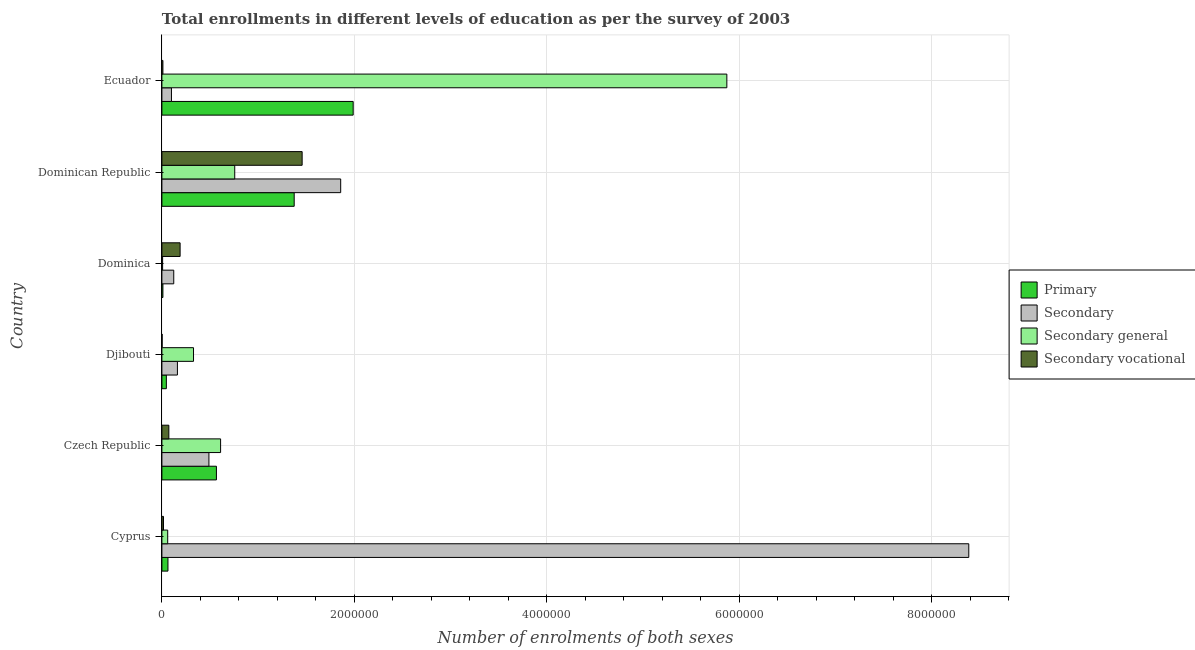How many different coloured bars are there?
Provide a short and direct response. 4. How many bars are there on the 3rd tick from the top?
Provide a short and direct response. 4. What is the label of the 3rd group of bars from the top?
Ensure brevity in your answer.  Dominica. In how many cases, is the number of bars for a given country not equal to the number of legend labels?
Your response must be concise. 0. What is the number of enrolments in primary education in Ecuador?
Ensure brevity in your answer.  1.99e+06. Across all countries, what is the maximum number of enrolments in secondary vocational education?
Give a very brief answer. 1.46e+06. Across all countries, what is the minimum number of enrolments in primary education?
Offer a very short reply. 1.05e+04. In which country was the number of enrolments in primary education maximum?
Your answer should be compact. Ecuador. In which country was the number of enrolments in secondary vocational education minimum?
Offer a very short reply. Djibouti. What is the total number of enrolments in secondary general education in the graph?
Your answer should be very brief. 7.63e+06. What is the difference between the number of enrolments in primary education in Dominica and that in Ecuador?
Keep it short and to the point. -1.98e+06. What is the difference between the number of enrolments in secondary vocational education in Czech Republic and the number of enrolments in secondary education in Djibouti?
Provide a short and direct response. -8.91e+04. What is the average number of enrolments in secondary general education per country?
Give a very brief answer. 1.27e+06. What is the difference between the number of enrolments in secondary education and number of enrolments in secondary vocational education in Dominica?
Give a very brief answer. -6.62e+04. In how many countries, is the number of enrolments in secondary general education greater than 800000 ?
Make the answer very short. 1. What is the ratio of the number of enrolments in secondary general education in Czech Republic to that in Djibouti?
Your answer should be very brief. 1.86. Is the difference between the number of enrolments in secondary education in Dominican Republic and Ecuador greater than the difference between the number of enrolments in primary education in Dominican Republic and Ecuador?
Ensure brevity in your answer.  Yes. What is the difference between the highest and the second highest number of enrolments in secondary vocational education?
Your answer should be very brief. 1.27e+06. What is the difference between the highest and the lowest number of enrolments in primary education?
Make the answer very short. 1.98e+06. Is the sum of the number of enrolments in primary education in Czech Republic and Dominica greater than the maximum number of enrolments in secondary vocational education across all countries?
Make the answer very short. No. What does the 4th bar from the top in Dominica represents?
Your response must be concise. Primary. What does the 1st bar from the bottom in Dominican Republic represents?
Your response must be concise. Primary. How many bars are there?
Make the answer very short. 24. Are all the bars in the graph horizontal?
Provide a short and direct response. Yes. Are the values on the major ticks of X-axis written in scientific E-notation?
Offer a very short reply. No. Does the graph contain any zero values?
Make the answer very short. No. How are the legend labels stacked?
Give a very brief answer. Vertical. What is the title of the graph?
Ensure brevity in your answer.  Total enrollments in different levels of education as per the survey of 2003. Does "Secondary vocational" appear as one of the legend labels in the graph?
Make the answer very short. Yes. What is the label or title of the X-axis?
Offer a terse response. Number of enrolments of both sexes. What is the label or title of the Y-axis?
Offer a very short reply. Country. What is the Number of enrolments of both sexes in Primary in Cyprus?
Your answer should be compact. 6.29e+04. What is the Number of enrolments of both sexes in Secondary in Cyprus?
Your answer should be compact. 8.38e+06. What is the Number of enrolments of both sexes of Secondary general in Cyprus?
Give a very brief answer. 6.03e+04. What is the Number of enrolments of both sexes of Secondary vocational in Cyprus?
Your response must be concise. 1.65e+04. What is the Number of enrolments of both sexes of Primary in Czech Republic?
Your response must be concise. 5.67e+05. What is the Number of enrolments of both sexes of Secondary in Czech Republic?
Offer a very short reply. 4.89e+05. What is the Number of enrolments of both sexes in Secondary general in Czech Republic?
Provide a succinct answer. 6.10e+05. What is the Number of enrolments of both sexes in Secondary vocational in Czech Republic?
Keep it short and to the point. 7.22e+04. What is the Number of enrolments of both sexes in Primary in Djibouti?
Offer a terse response. 4.64e+04. What is the Number of enrolments of both sexes in Secondary in Djibouti?
Your answer should be compact. 1.61e+05. What is the Number of enrolments of both sexes in Secondary general in Djibouti?
Give a very brief answer. 3.29e+05. What is the Number of enrolments of both sexes in Secondary vocational in Djibouti?
Your response must be concise. 2319. What is the Number of enrolments of both sexes of Primary in Dominica?
Your answer should be very brief. 1.05e+04. What is the Number of enrolments of both sexes of Secondary in Dominica?
Your answer should be very brief. 1.23e+05. What is the Number of enrolments of both sexes of Secondary general in Dominica?
Provide a succinct answer. 7318. What is the Number of enrolments of both sexes of Secondary vocational in Dominica?
Offer a terse response. 1.89e+05. What is the Number of enrolments of both sexes of Primary in Dominican Republic?
Give a very brief answer. 1.37e+06. What is the Number of enrolments of both sexes of Secondary in Dominican Republic?
Your answer should be very brief. 1.86e+06. What is the Number of enrolments of both sexes of Secondary general in Dominican Republic?
Your response must be concise. 7.57e+05. What is the Number of enrolments of both sexes of Secondary vocational in Dominican Republic?
Your answer should be very brief. 1.46e+06. What is the Number of enrolments of both sexes of Primary in Ecuador?
Your response must be concise. 1.99e+06. What is the Number of enrolments of both sexes of Secondary in Ecuador?
Keep it short and to the point. 9.92e+04. What is the Number of enrolments of both sexes of Secondary general in Ecuador?
Give a very brief answer. 5.87e+06. What is the Number of enrolments of both sexes in Secondary vocational in Ecuador?
Keep it short and to the point. 1.04e+04. Across all countries, what is the maximum Number of enrolments of both sexes in Primary?
Your answer should be very brief. 1.99e+06. Across all countries, what is the maximum Number of enrolments of both sexes in Secondary?
Offer a terse response. 8.38e+06. Across all countries, what is the maximum Number of enrolments of both sexes of Secondary general?
Your answer should be very brief. 5.87e+06. Across all countries, what is the maximum Number of enrolments of both sexes of Secondary vocational?
Ensure brevity in your answer.  1.46e+06. Across all countries, what is the minimum Number of enrolments of both sexes in Primary?
Provide a short and direct response. 1.05e+04. Across all countries, what is the minimum Number of enrolments of both sexes in Secondary?
Ensure brevity in your answer.  9.92e+04. Across all countries, what is the minimum Number of enrolments of both sexes of Secondary general?
Provide a short and direct response. 7318. Across all countries, what is the minimum Number of enrolments of both sexes in Secondary vocational?
Offer a terse response. 2319. What is the total Number of enrolments of both sexes in Primary in the graph?
Make the answer very short. 4.05e+06. What is the total Number of enrolments of both sexes in Secondary in the graph?
Keep it short and to the point. 1.11e+07. What is the total Number of enrolments of both sexes in Secondary general in the graph?
Give a very brief answer. 7.63e+06. What is the total Number of enrolments of both sexes in Secondary vocational in the graph?
Provide a short and direct response. 1.75e+06. What is the difference between the Number of enrolments of both sexes in Primary in Cyprus and that in Czech Republic?
Ensure brevity in your answer.  -5.04e+05. What is the difference between the Number of enrolments of both sexes in Secondary in Cyprus and that in Czech Republic?
Your answer should be compact. 7.90e+06. What is the difference between the Number of enrolments of both sexes of Secondary general in Cyprus and that in Czech Republic?
Offer a very short reply. -5.49e+05. What is the difference between the Number of enrolments of both sexes in Secondary vocational in Cyprus and that in Czech Republic?
Provide a succinct answer. -5.56e+04. What is the difference between the Number of enrolments of both sexes of Primary in Cyprus and that in Djibouti?
Your answer should be compact. 1.65e+04. What is the difference between the Number of enrolments of both sexes of Secondary in Cyprus and that in Djibouti?
Make the answer very short. 8.22e+06. What is the difference between the Number of enrolments of both sexes in Secondary general in Cyprus and that in Djibouti?
Offer a very short reply. -2.68e+05. What is the difference between the Number of enrolments of both sexes of Secondary vocational in Cyprus and that in Djibouti?
Your answer should be very brief. 1.42e+04. What is the difference between the Number of enrolments of both sexes of Primary in Cyprus and that in Dominica?
Ensure brevity in your answer.  5.24e+04. What is the difference between the Number of enrolments of both sexes in Secondary in Cyprus and that in Dominica?
Offer a very short reply. 8.26e+06. What is the difference between the Number of enrolments of both sexes of Secondary general in Cyprus and that in Dominica?
Ensure brevity in your answer.  5.30e+04. What is the difference between the Number of enrolments of both sexes of Secondary vocational in Cyprus and that in Dominica?
Your answer should be very brief. -1.73e+05. What is the difference between the Number of enrolments of both sexes in Primary in Cyprus and that in Dominican Republic?
Ensure brevity in your answer.  -1.31e+06. What is the difference between the Number of enrolments of both sexes of Secondary in Cyprus and that in Dominican Republic?
Offer a terse response. 6.53e+06. What is the difference between the Number of enrolments of both sexes in Secondary general in Cyprus and that in Dominican Republic?
Ensure brevity in your answer.  -6.96e+05. What is the difference between the Number of enrolments of both sexes of Secondary vocational in Cyprus and that in Dominican Republic?
Keep it short and to the point. -1.44e+06. What is the difference between the Number of enrolments of both sexes in Primary in Cyprus and that in Ecuador?
Your answer should be compact. -1.92e+06. What is the difference between the Number of enrolments of both sexes of Secondary in Cyprus and that in Ecuador?
Your response must be concise. 8.28e+06. What is the difference between the Number of enrolments of both sexes of Secondary general in Cyprus and that in Ecuador?
Your answer should be very brief. -5.81e+06. What is the difference between the Number of enrolments of both sexes of Secondary vocational in Cyprus and that in Ecuador?
Your answer should be compact. 6096. What is the difference between the Number of enrolments of both sexes of Primary in Czech Republic and that in Djibouti?
Give a very brief answer. 5.20e+05. What is the difference between the Number of enrolments of both sexes of Secondary in Czech Republic and that in Djibouti?
Ensure brevity in your answer.  3.27e+05. What is the difference between the Number of enrolments of both sexes of Secondary general in Czech Republic and that in Djibouti?
Your response must be concise. 2.81e+05. What is the difference between the Number of enrolments of both sexes of Secondary vocational in Czech Republic and that in Djibouti?
Your answer should be very brief. 6.98e+04. What is the difference between the Number of enrolments of both sexes in Primary in Czech Republic and that in Dominica?
Offer a terse response. 5.56e+05. What is the difference between the Number of enrolments of both sexes in Secondary in Czech Republic and that in Dominica?
Your answer should be compact. 3.65e+05. What is the difference between the Number of enrolments of both sexes in Secondary general in Czech Republic and that in Dominica?
Provide a short and direct response. 6.03e+05. What is the difference between the Number of enrolments of both sexes in Secondary vocational in Czech Republic and that in Dominica?
Offer a terse response. -1.17e+05. What is the difference between the Number of enrolments of both sexes of Primary in Czech Republic and that in Dominican Republic?
Provide a short and direct response. -8.08e+05. What is the difference between the Number of enrolments of both sexes in Secondary in Czech Republic and that in Dominican Republic?
Offer a very short reply. -1.37e+06. What is the difference between the Number of enrolments of both sexes in Secondary general in Czech Republic and that in Dominican Republic?
Ensure brevity in your answer.  -1.47e+05. What is the difference between the Number of enrolments of both sexes in Secondary vocational in Czech Republic and that in Dominican Republic?
Keep it short and to the point. -1.39e+06. What is the difference between the Number of enrolments of both sexes of Primary in Czech Republic and that in Ecuador?
Provide a short and direct response. -1.42e+06. What is the difference between the Number of enrolments of both sexes of Secondary in Czech Republic and that in Ecuador?
Offer a very short reply. 3.89e+05. What is the difference between the Number of enrolments of both sexes of Secondary general in Czech Republic and that in Ecuador?
Provide a succinct answer. -5.26e+06. What is the difference between the Number of enrolments of both sexes of Secondary vocational in Czech Republic and that in Ecuador?
Your response must be concise. 6.17e+04. What is the difference between the Number of enrolments of both sexes in Primary in Djibouti and that in Dominica?
Give a very brief answer. 3.59e+04. What is the difference between the Number of enrolments of both sexes in Secondary in Djibouti and that in Dominica?
Keep it short and to the point. 3.82e+04. What is the difference between the Number of enrolments of both sexes in Secondary general in Djibouti and that in Dominica?
Your answer should be compact. 3.21e+05. What is the difference between the Number of enrolments of both sexes of Secondary vocational in Djibouti and that in Dominica?
Offer a very short reply. -1.87e+05. What is the difference between the Number of enrolments of both sexes in Primary in Djibouti and that in Dominican Republic?
Your response must be concise. -1.33e+06. What is the difference between the Number of enrolments of both sexes in Secondary in Djibouti and that in Dominican Republic?
Keep it short and to the point. -1.70e+06. What is the difference between the Number of enrolments of both sexes of Secondary general in Djibouti and that in Dominican Republic?
Make the answer very short. -4.28e+05. What is the difference between the Number of enrolments of both sexes in Secondary vocational in Djibouti and that in Dominican Republic?
Make the answer very short. -1.45e+06. What is the difference between the Number of enrolments of both sexes of Primary in Djibouti and that in Ecuador?
Offer a terse response. -1.94e+06. What is the difference between the Number of enrolments of both sexes in Secondary in Djibouti and that in Ecuador?
Give a very brief answer. 6.21e+04. What is the difference between the Number of enrolments of both sexes in Secondary general in Djibouti and that in Ecuador?
Give a very brief answer. -5.54e+06. What is the difference between the Number of enrolments of both sexes in Secondary vocational in Djibouti and that in Ecuador?
Your answer should be very brief. -8129. What is the difference between the Number of enrolments of both sexes of Primary in Dominica and that in Dominican Republic?
Offer a very short reply. -1.36e+06. What is the difference between the Number of enrolments of both sexes in Secondary in Dominica and that in Dominican Republic?
Your answer should be very brief. -1.73e+06. What is the difference between the Number of enrolments of both sexes in Secondary general in Dominica and that in Dominican Republic?
Give a very brief answer. -7.50e+05. What is the difference between the Number of enrolments of both sexes in Secondary vocational in Dominica and that in Dominican Republic?
Your answer should be compact. -1.27e+06. What is the difference between the Number of enrolments of both sexes in Primary in Dominica and that in Ecuador?
Your answer should be compact. -1.98e+06. What is the difference between the Number of enrolments of both sexes in Secondary in Dominica and that in Ecuador?
Your answer should be compact. 2.39e+04. What is the difference between the Number of enrolments of both sexes of Secondary general in Dominica and that in Ecuador?
Your answer should be compact. -5.86e+06. What is the difference between the Number of enrolments of both sexes in Secondary vocational in Dominica and that in Ecuador?
Your response must be concise. 1.79e+05. What is the difference between the Number of enrolments of both sexes in Primary in Dominican Republic and that in Ecuador?
Offer a very short reply. -6.13e+05. What is the difference between the Number of enrolments of both sexes of Secondary in Dominican Republic and that in Ecuador?
Your response must be concise. 1.76e+06. What is the difference between the Number of enrolments of both sexes of Secondary general in Dominican Republic and that in Ecuador?
Ensure brevity in your answer.  -5.11e+06. What is the difference between the Number of enrolments of both sexes in Secondary vocational in Dominican Republic and that in Ecuador?
Your answer should be very brief. 1.45e+06. What is the difference between the Number of enrolments of both sexes of Primary in Cyprus and the Number of enrolments of both sexes of Secondary in Czech Republic?
Offer a terse response. -4.26e+05. What is the difference between the Number of enrolments of both sexes of Primary in Cyprus and the Number of enrolments of both sexes of Secondary general in Czech Republic?
Your answer should be compact. -5.47e+05. What is the difference between the Number of enrolments of both sexes of Primary in Cyprus and the Number of enrolments of both sexes of Secondary vocational in Czech Republic?
Give a very brief answer. -9294. What is the difference between the Number of enrolments of both sexes of Secondary in Cyprus and the Number of enrolments of both sexes of Secondary general in Czech Republic?
Your answer should be very brief. 7.77e+06. What is the difference between the Number of enrolments of both sexes of Secondary in Cyprus and the Number of enrolments of both sexes of Secondary vocational in Czech Republic?
Make the answer very short. 8.31e+06. What is the difference between the Number of enrolments of both sexes of Secondary general in Cyprus and the Number of enrolments of both sexes of Secondary vocational in Czech Republic?
Give a very brief answer. -1.18e+04. What is the difference between the Number of enrolments of both sexes in Primary in Cyprus and the Number of enrolments of both sexes in Secondary in Djibouti?
Provide a succinct answer. -9.84e+04. What is the difference between the Number of enrolments of both sexes of Primary in Cyprus and the Number of enrolments of both sexes of Secondary general in Djibouti?
Provide a short and direct response. -2.66e+05. What is the difference between the Number of enrolments of both sexes in Primary in Cyprus and the Number of enrolments of both sexes in Secondary vocational in Djibouti?
Give a very brief answer. 6.05e+04. What is the difference between the Number of enrolments of both sexes of Secondary in Cyprus and the Number of enrolments of both sexes of Secondary general in Djibouti?
Your answer should be compact. 8.06e+06. What is the difference between the Number of enrolments of both sexes of Secondary in Cyprus and the Number of enrolments of both sexes of Secondary vocational in Djibouti?
Ensure brevity in your answer.  8.38e+06. What is the difference between the Number of enrolments of both sexes of Secondary general in Cyprus and the Number of enrolments of both sexes of Secondary vocational in Djibouti?
Ensure brevity in your answer.  5.80e+04. What is the difference between the Number of enrolments of both sexes of Primary in Cyprus and the Number of enrolments of both sexes of Secondary in Dominica?
Your answer should be compact. -6.02e+04. What is the difference between the Number of enrolments of both sexes in Primary in Cyprus and the Number of enrolments of both sexes in Secondary general in Dominica?
Provide a succinct answer. 5.56e+04. What is the difference between the Number of enrolments of both sexes of Primary in Cyprus and the Number of enrolments of both sexes of Secondary vocational in Dominica?
Your answer should be compact. -1.26e+05. What is the difference between the Number of enrolments of both sexes of Secondary in Cyprus and the Number of enrolments of both sexes of Secondary general in Dominica?
Provide a short and direct response. 8.38e+06. What is the difference between the Number of enrolments of both sexes of Secondary in Cyprus and the Number of enrolments of both sexes of Secondary vocational in Dominica?
Offer a terse response. 8.19e+06. What is the difference between the Number of enrolments of both sexes in Secondary general in Cyprus and the Number of enrolments of both sexes in Secondary vocational in Dominica?
Provide a succinct answer. -1.29e+05. What is the difference between the Number of enrolments of both sexes of Primary in Cyprus and the Number of enrolments of both sexes of Secondary in Dominican Republic?
Make the answer very short. -1.79e+06. What is the difference between the Number of enrolments of both sexes in Primary in Cyprus and the Number of enrolments of both sexes in Secondary general in Dominican Republic?
Provide a succinct answer. -6.94e+05. What is the difference between the Number of enrolments of both sexes of Primary in Cyprus and the Number of enrolments of both sexes of Secondary vocational in Dominican Republic?
Ensure brevity in your answer.  -1.39e+06. What is the difference between the Number of enrolments of both sexes in Secondary in Cyprus and the Number of enrolments of both sexes in Secondary general in Dominican Republic?
Ensure brevity in your answer.  7.63e+06. What is the difference between the Number of enrolments of both sexes of Secondary in Cyprus and the Number of enrolments of both sexes of Secondary vocational in Dominican Republic?
Your answer should be compact. 6.93e+06. What is the difference between the Number of enrolments of both sexes of Secondary general in Cyprus and the Number of enrolments of both sexes of Secondary vocational in Dominican Republic?
Offer a terse response. -1.40e+06. What is the difference between the Number of enrolments of both sexes of Primary in Cyprus and the Number of enrolments of both sexes of Secondary in Ecuador?
Give a very brief answer. -3.63e+04. What is the difference between the Number of enrolments of both sexes of Primary in Cyprus and the Number of enrolments of both sexes of Secondary general in Ecuador?
Make the answer very short. -5.81e+06. What is the difference between the Number of enrolments of both sexes in Primary in Cyprus and the Number of enrolments of both sexes in Secondary vocational in Ecuador?
Give a very brief answer. 5.24e+04. What is the difference between the Number of enrolments of both sexes of Secondary in Cyprus and the Number of enrolments of both sexes of Secondary general in Ecuador?
Your answer should be compact. 2.51e+06. What is the difference between the Number of enrolments of both sexes in Secondary in Cyprus and the Number of enrolments of both sexes in Secondary vocational in Ecuador?
Make the answer very short. 8.37e+06. What is the difference between the Number of enrolments of both sexes in Secondary general in Cyprus and the Number of enrolments of both sexes in Secondary vocational in Ecuador?
Offer a terse response. 4.99e+04. What is the difference between the Number of enrolments of both sexes in Primary in Czech Republic and the Number of enrolments of both sexes in Secondary in Djibouti?
Provide a succinct answer. 4.05e+05. What is the difference between the Number of enrolments of both sexes in Primary in Czech Republic and the Number of enrolments of both sexes in Secondary general in Djibouti?
Your answer should be compact. 2.38e+05. What is the difference between the Number of enrolments of both sexes of Primary in Czech Republic and the Number of enrolments of both sexes of Secondary vocational in Djibouti?
Your response must be concise. 5.64e+05. What is the difference between the Number of enrolments of both sexes in Secondary in Czech Republic and the Number of enrolments of both sexes in Secondary general in Djibouti?
Offer a very short reply. 1.60e+05. What is the difference between the Number of enrolments of both sexes in Secondary in Czech Republic and the Number of enrolments of both sexes in Secondary vocational in Djibouti?
Your answer should be very brief. 4.86e+05. What is the difference between the Number of enrolments of both sexes of Secondary general in Czech Republic and the Number of enrolments of both sexes of Secondary vocational in Djibouti?
Offer a very short reply. 6.08e+05. What is the difference between the Number of enrolments of both sexes of Primary in Czech Republic and the Number of enrolments of both sexes of Secondary in Dominica?
Give a very brief answer. 4.44e+05. What is the difference between the Number of enrolments of both sexes in Primary in Czech Republic and the Number of enrolments of both sexes in Secondary general in Dominica?
Your response must be concise. 5.59e+05. What is the difference between the Number of enrolments of both sexes of Primary in Czech Republic and the Number of enrolments of both sexes of Secondary vocational in Dominica?
Provide a short and direct response. 3.77e+05. What is the difference between the Number of enrolments of both sexes in Secondary in Czech Republic and the Number of enrolments of both sexes in Secondary general in Dominica?
Give a very brief answer. 4.81e+05. What is the difference between the Number of enrolments of both sexes in Secondary in Czech Republic and the Number of enrolments of both sexes in Secondary vocational in Dominica?
Your answer should be very brief. 2.99e+05. What is the difference between the Number of enrolments of both sexes in Secondary general in Czech Republic and the Number of enrolments of both sexes in Secondary vocational in Dominica?
Your answer should be very brief. 4.21e+05. What is the difference between the Number of enrolments of both sexes in Primary in Czech Republic and the Number of enrolments of both sexes in Secondary in Dominican Republic?
Make the answer very short. -1.29e+06. What is the difference between the Number of enrolments of both sexes in Primary in Czech Republic and the Number of enrolments of both sexes in Secondary general in Dominican Republic?
Your answer should be very brief. -1.90e+05. What is the difference between the Number of enrolments of both sexes in Primary in Czech Republic and the Number of enrolments of both sexes in Secondary vocational in Dominican Republic?
Offer a terse response. -8.91e+05. What is the difference between the Number of enrolments of both sexes of Secondary in Czech Republic and the Number of enrolments of both sexes of Secondary general in Dominican Republic?
Offer a very short reply. -2.68e+05. What is the difference between the Number of enrolments of both sexes of Secondary in Czech Republic and the Number of enrolments of both sexes of Secondary vocational in Dominican Republic?
Ensure brevity in your answer.  -9.69e+05. What is the difference between the Number of enrolments of both sexes of Secondary general in Czech Republic and the Number of enrolments of both sexes of Secondary vocational in Dominican Republic?
Keep it short and to the point. -8.47e+05. What is the difference between the Number of enrolments of both sexes in Primary in Czech Republic and the Number of enrolments of both sexes in Secondary in Ecuador?
Offer a terse response. 4.67e+05. What is the difference between the Number of enrolments of both sexes in Primary in Czech Republic and the Number of enrolments of both sexes in Secondary general in Ecuador?
Your answer should be compact. -5.30e+06. What is the difference between the Number of enrolments of both sexes of Primary in Czech Republic and the Number of enrolments of both sexes of Secondary vocational in Ecuador?
Your response must be concise. 5.56e+05. What is the difference between the Number of enrolments of both sexes of Secondary in Czech Republic and the Number of enrolments of both sexes of Secondary general in Ecuador?
Provide a succinct answer. -5.38e+06. What is the difference between the Number of enrolments of both sexes of Secondary in Czech Republic and the Number of enrolments of both sexes of Secondary vocational in Ecuador?
Make the answer very short. 4.78e+05. What is the difference between the Number of enrolments of both sexes of Secondary general in Czech Republic and the Number of enrolments of both sexes of Secondary vocational in Ecuador?
Make the answer very short. 5.99e+05. What is the difference between the Number of enrolments of both sexes in Primary in Djibouti and the Number of enrolments of both sexes in Secondary in Dominica?
Ensure brevity in your answer.  -7.67e+04. What is the difference between the Number of enrolments of both sexes of Primary in Djibouti and the Number of enrolments of both sexes of Secondary general in Dominica?
Your response must be concise. 3.90e+04. What is the difference between the Number of enrolments of both sexes in Primary in Djibouti and the Number of enrolments of both sexes in Secondary vocational in Dominica?
Offer a very short reply. -1.43e+05. What is the difference between the Number of enrolments of both sexes in Secondary in Djibouti and the Number of enrolments of both sexes in Secondary general in Dominica?
Ensure brevity in your answer.  1.54e+05. What is the difference between the Number of enrolments of both sexes in Secondary in Djibouti and the Number of enrolments of both sexes in Secondary vocational in Dominica?
Your response must be concise. -2.80e+04. What is the difference between the Number of enrolments of both sexes in Secondary general in Djibouti and the Number of enrolments of both sexes in Secondary vocational in Dominica?
Offer a very short reply. 1.39e+05. What is the difference between the Number of enrolments of both sexes in Primary in Djibouti and the Number of enrolments of both sexes in Secondary in Dominican Republic?
Your answer should be very brief. -1.81e+06. What is the difference between the Number of enrolments of both sexes of Primary in Djibouti and the Number of enrolments of both sexes of Secondary general in Dominican Republic?
Offer a terse response. -7.10e+05. What is the difference between the Number of enrolments of both sexes in Primary in Djibouti and the Number of enrolments of both sexes in Secondary vocational in Dominican Republic?
Give a very brief answer. -1.41e+06. What is the difference between the Number of enrolments of both sexes in Secondary in Djibouti and the Number of enrolments of both sexes in Secondary general in Dominican Republic?
Give a very brief answer. -5.96e+05. What is the difference between the Number of enrolments of both sexes in Secondary in Djibouti and the Number of enrolments of both sexes in Secondary vocational in Dominican Republic?
Your answer should be very brief. -1.30e+06. What is the difference between the Number of enrolments of both sexes in Secondary general in Djibouti and the Number of enrolments of both sexes in Secondary vocational in Dominican Republic?
Provide a short and direct response. -1.13e+06. What is the difference between the Number of enrolments of both sexes in Primary in Djibouti and the Number of enrolments of both sexes in Secondary in Ecuador?
Your answer should be compact. -5.28e+04. What is the difference between the Number of enrolments of both sexes of Primary in Djibouti and the Number of enrolments of both sexes of Secondary general in Ecuador?
Provide a short and direct response. -5.82e+06. What is the difference between the Number of enrolments of both sexes of Primary in Djibouti and the Number of enrolments of both sexes of Secondary vocational in Ecuador?
Offer a very short reply. 3.59e+04. What is the difference between the Number of enrolments of both sexes of Secondary in Djibouti and the Number of enrolments of both sexes of Secondary general in Ecuador?
Provide a succinct answer. -5.71e+06. What is the difference between the Number of enrolments of both sexes in Secondary in Djibouti and the Number of enrolments of both sexes in Secondary vocational in Ecuador?
Provide a succinct answer. 1.51e+05. What is the difference between the Number of enrolments of both sexes of Secondary general in Djibouti and the Number of enrolments of both sexes of Secondary vocational in Ecuador?
Your answer should be compact. 3.18e+05. What is the difference between the Number of enrolments of both sexes of Primary in Dominica and the Number of enrolments of both sexes of Secondary in Dominican Republic?
Ensure brevity in your answer.  -1.85e+06. What is the difference between the Number of enrolments of both sexes of Primary in Dominica and the Number of enrolments of both sexes of Secondary general in Dominican Republic?
Provide a short and direct response. -7.46e+05. What is the difference between the Number of enrolments of both sexes of Primary in Dominica and the Number of enrolments of both sexes of Secondary vocational in Dominican Republic?
Offer a terse response. -1.45e+06. What is the difference between the Number of enrolments of both sexes of Secondary in Dominica and the Number of enrolments of both sexes of Secondary general in Dominican Republic?
Your answer should be very brief. -6.34e+05. What is the difference between the Number of enrolments of both sexes of Secondary in Dominica and the Number of enrolments of both sexes of Secondary vocational in Dominican Republic?
Give a very brief answer. -1.33e+06. What is the difference between the Number of enrolments of both sexes in Secondary general in Dominica and the Number of enrolments of both sexes in Secondary vocational in Dominican Republic?
Provide a succinct answer. -1.45e+06. What is the difference between the Number of enrolments of both sexes of Primary in Dominica and the Number of enrolments of both sexes of Secondary in Ecuador?
Provide a succinct answer. -8.88e+04. What is the difference between the Number of enrolments of both sexes in Primary in Dominica and the Number of enrolments of both sexes in Secondary general in Ecuador?
Your answer should be compact. -5.86e+06. What is the difference between the Number of enrolments of both sexes in Primary in Dominica and the Number of enrolments of both sexes in Secondary vocational in Ecuador?
Give a very brief answer. 12. What is the difference between the Number of enrolments of both sexes of Secondary in Dominica and the Number of enrolments of both sexes of Secondary general in Ecuador?
Your response must be concise. -5.75e+06. What is the difference between the Number of enrolments of both sexes of Secondary in Dominica and the Number of enrolments of both sexes of Secondary vocational in Ecuador?
Your response must be concise. 1.13e+05. What is the difference between the Number of enrolments of both sexes of Secondary general in Dominica and the Number of enrolments of both sexes of Secondary vocational in Ecuador?
Your answer should be very brief. -3130. What is the difference between the Number of enrolments of both sexes of Primary in Dominican Republic and the Number of enrolments of both sexes of Secondary in Ecuador?
Give a very brief answer. 1.28e+06. What is the difference between the Number of enrolments of both sexes in Primary in Dominican Republic and the Number of enrolments of both sexes in Secondary general in Ecuador?
Provide a short and direct response. -4.50e+06. What is the difference between the Number of enrolments of both sexes of Primary in Dominican Republic and the Number of enrolments of both sexes of Secondary vocational in Ecuador?
Keep it short and to the point. 1.36e+06. What is the difference between the Number of enrolments of both sexes in Secondary in Dominican Republic and the Number of enrolments of both sexes in Secondary general in Ecuador?
Keep it short and to the point. -4.01e+06. What is the difference between the Number of enrolments of both sexes of Secondary in Dominican Republic and the Number of enrolments of both sexes of Secondary vocational in Ecuador?
Provide a succinct answer. 1.85e+06. What is the difference between the Number of enrolments of both sexes in Secondary general in Dominican Republic and the Number of enrolments of both sexes in Secondary vocational in Ecuador?
Offer a very short reply. 7.46e+05. What is the average Number of enrolments of both sexes of Primary per country?
Keep it short and to the point. 6.75e+05. What is the average Number of enrolments of both sexes in Secondary per country?
Provide a short and direct response. 1.85e+06. What is the average Number of enrolments of both sexes of Secondary general per country?
Keep it short and to the point. 1.27e+06. What is the average Number of enrolments of both sexes of Secondary vocational per country?
Your answer should be very brief. 2.91e+05. What is the difference between the Number of enrolments of both sexes in Primary and Number of enrolments of both sexes in Secondary in Cyprus?
Make the answer very short. -8.32e+06. What is the difference between the Number of enrolments of both sexes in Primary and Number of enrolments of both sexes in Secondary general in Cyprus?
Your response must be concise. 2520. What is the difference between the Number of enrolments of both sexes of Primary and Number of enrolments of both sexes of Secondary vocational in Cyprus?
Make the answer very short. 4.63e+04. What is the difference between the Number of enrolments of both sexes of Secondary and Number of enrolments of both sexes of Secondary general in Cyprus?
Your response must be concise. 8.32e+06. What is the difference between the Number of enrolments of both sexes of Secondary and Number of enrolments of both sexes of Secondary vocational in Cyprus?
Provide a succinct answer. 8.37e+06. What is the difference between the Number of enrolments of both sexes of Secondary general and Number of enrolments of both sexes of Secondary vocational in Cyprus?
Provide a succinct answer. 4.38e+04. What is the difference between the Number of enrolments of both sexes in Primary and Number of enrolments of both sexes in Secondary in Czech Republic?
Offer a terse response. 7.81e+04. What is the difference between the Number of enrolments of both sexes of Primary and Number of enrolments of both sexes of Secondary general in Czech Republic?
Provide a succinct answer. -4.33e+04. What is the difference between the Number of enrolments of both sexes of Primary and Number of enrolments of both sexes of Secondary vocational in Czech Republic?
Your response must be concise. 4.94e+05. What is the difference between the Number of enrolments of both sexes in Secondary and Number of enrolments of both sexes in Secondary general in Czech Republic?
Provide a short and direct response. -1.21e+05. What is the difference between the Number of enrolments of both sexes of Secondary and Number of enrolments of both sexes of Secondary vocational in Czech Republic?
Provide a short and direct response. 4.16e+05. What is the difference between the Number of enrolments of both sexes of Secondary general and Number of enrolments of both sexes of Secondary vocational in Czech Republic?
Offer a very short reply. 5.38e+05. What is the difference between the Number of enrolments of both sexes of Primary and Number of enrolments of both sexes of Secondary in Djibouti?
Your answer should be very brief. -1.15e+05. What is the difference between the Number of enrolments of both sexes in Primary and Number of enrolments of both sexes in Secondary general in Djibouti?
Ensure brevity in your answer.  -2.82e+05. What is the difference between the Number of enrolments of both sexes of Primary and Number of enrolments of both sexes of Secondary vocational in Djibouti?
Provide a succinct answer. 4.40e+04. What is the difference between the Number of enrolments of both sexes in Secondary and Number of enrolments of both sexes in Secondary general in Djibouti?
Provide a succinct answer. -1.67e+05. What is the difference between the Number of enrolments of both sexes in Secondary and Number of enrolments of both sexes in Secondary vocational in Djibouti?
Your answer should be very brief. 1.59e+05. What is the difference between the Number of enrolments of both sexes of Secondary general and Number of enrolments of both sexes of Secondary vocational in Djibouti?
Your response must be concise. 3.26e+05. What is the difference between the Number of enrolments of both sexes in Primary and Number of enrolments of both sexes in Secondary in Dominica?
Provide a succinct answer. -1.13e+05. What is the difference between the Number of enrolments of both sexes of Primary and Number of enrolments of both sexes of Secondary general in Dominica?
Provide a succinct answer. 3142. What is the difference between the Number of enrolments of both sexes of Primary and Number of enrolments of both sexes of Secondary vocational in Dominica?
Ensure brevity in your answer.  -1.79e+05. What is the difference between the Number of enrolments of both sexes of Secondary and Number of enrolments of both sexes of Secondary general in Dominica?
Your answer should be very brief. 1.16e+05. What is the difference between the Number of enrolments of both sexes of Secondary and Number of enrolments of both sexes of Secondary vocational in Dominica?
Offer a terse response. -6.62e+04. What is the difference between the Number of enrolments of both sexes of Secondary general and Number of enrolments of both sexes of Secondary vocational in Dominica?
Provide a succinct answer. -1.82e+05. What is the difference between the Number of enrolments of both sexes of Primary and Number of enrolments of both sexes of Secondary in Dominican Republic?
Make the answer very short. -4.83e+05. What is the difference between the Number of enrolments of both sexes in Primary and Number of enrolments of both sexes in Secondary general in Dominican Republic?
Provide a short and direct response. 6.18e+05. What is the difference between the Number of enrolments of both sexes in Primary and Number of enrolments of both sexes in Secondary vocational in Dominican Republic?
Your response must be concise. -8.26e+04. What is the difference between the Number of enrolments of both sexes in Secondary and Number of enrolments of both sexes in Secondary general in Dominican Republic?
Ensure brevity in your answer.  1.10e+06. What is the difference between the Number of enrolments of both sexes of Secondary and Number of enrolments of both sexes of Secondary vocational in Dominican Republic?
Your response must be concise. 4.01e+05. What is the difference between the Number of enrolments of both sexes in Secondary general and Number of enrolments of both sexes in Secondary vocational in Dominican Republic?
Your answer should be compact. -7.00e+05. What is the difference between the Number of enrolments of both sexes of Primary and Number of enrolments of both sexes of Secondary in Ecuador?
Provide a short and direct response. 1.89e+06. What is the difference between the Number of enrolments of both sexes in Primary and Number of enrolments of both sexes in Secondary general in Ecuador?
Your answer should be compact. -3.88e+06. What is the difference between the Number of enrolments of both sexes in Primary and Number of enrolments of both sexes in Secondary vocational in Ecuador?
Offer a terse response. 1.98e+06. What is the difference between the Number of enrolments of both sexes of Secondary and Number of enrolments of both sexes of Secondary general in Ecuador?
Your response must be concise. -5.77e+06. What is the difference between the Number of enrolments of both sexes in Secondary and Number of enrolments of both sexes in Secondary vocational in Ecuador?
Provide a succinct answer. 8.88e+04. What is the difference between the Number of enrolments of both sexes of Secondary general and Number of enrolments of both sexes of Secondary vocational in Ecuador?
Make the answer very short. 5.86e+06. What is the ratio of the Number of enrolments of both sexes of Primary in Cyprus to that in Czech Republic?
Offer a terse response. 0.11. What is the ratio of the Number of enrolments of both sexes of Secondary in Cyprus to that in Czech Republic?
Offer a terse response. 17.16. What is the ratio of the Number of enrolments of both sexes of Secondary general in Cyprus to that in Czech Republic?
Offer a terse response. 0.1. What is the ratio of the Number of enrolments of both sexes of Secondary vocational in Cyprus to that in Czech Republic?
Ensure brevity in your answer.  0.23. What is the ratio of the Number of enrolments of both sexes in Primary in Cyprus to that in Djibouti?
Provide a short and direct response. 1.36. What is the ratio of the Number of enrolments of both sexes of Secondary in Cyprus to that in Djibouti?
Keep it short and to the point. 51.99. What is the ratio of the Number of enrolments of both sexes of Secondary general in Cyprus to that in Djibouti?
Provide a short and direct response. 0.18. What is the ratio of the Number of enrolments of both sexes of Secondary vocational in Cyprus to that in Djibouti?
Ensure brevity in your answer.  7.13. What is the ratio of the Number of enrolments of both sexes in Primary in Cyprus to that in Dominica?
Provide a succinct answer. 6.01. What is the ratio of the Number of enrolments of both sexes in Secondary in Cyprus to that in Dominica?
Give a very brief answer. 68.12. What is the ratio of the Number of enrolments of both sexes of Secondary general in Cyprus to that in Dominica?
Your answer should be compact. 8.25. What is the ratio of the Number of enrolments of both sexes in Secondary vocational in Cyprus to that in Dominica?
Keep it short and to the point. 0.09. What is the ratio of the Number of enrolments of both sexes of Primary in Cyprus to that in Dominican Republic?
Make the answer very short. 0.05. What is the ratio of the Number of enrolments of both sexes of Secondary in Cyprus to that in Dominican Republic?
Ensure brevity in your answer.  4.51. What is the ratio of the Number of enrolments of both sexes in Secondary general in Cyprus to that in Dominican Republic?
Your answer should be compact. 0.08. What is the ratio of the Number of enrolments of both sexes of Secondary vocational in Cyprus to that in Dominican Republic?
Offer a very short reply. 0.01. What is the ratio of the Number of enrolments of both sexes in Primary in Cyprus to that in Ecuador?
Your response must be concise. 0.03. What is the ratio of the Number of enrolments of both sexes of Secondary in Cyprus to that in Ecuador?
Your answer should be compact. 84.51. What is the ratio of the Number of enrolments of both sexes of Secondary general in Cyprus to that in Ecuador?
Your answer should be very brief. 0.01. What is the ratio of the Number of enrolments of both sexes in Secondary vocational in Cyprus to that in Ecuador?
Provide a succinct answer. 1.58. What is the ratio of the Number of enrolments of both sexes in Primary in Czech Republic to that in Djibouti?
Offer a terse response. 12.22. What is the ratio of the Number of enrolments of both sexes in Secondary in Czech Republic to that in Djibouti?
Provide a succinct answer. 3.03. What is the ratio of the Number of enrolments of both sexes in Secondary general in Czech Republic to that in Djibouti?
Your answer should be compact. 1.86. What is the ratio of the Number of enrolments of both sexes of Secondary vocational in Czech Republic to that in Djibouti?
Ensure brevity in your answer.  31.12. What is the ratio of the Number of enrolments of both sexes in Primary in Czech Republic to that in Dominica?
Offer a terse response. 54.17. What is the ratio of the Number of enrolments of both sexes in Secondary in Czech Republic to that in Dominica?
Your answer should be very brief. 3.97. What is the ratio of the Number of enrolments of both sexes in Secondary general in Czech Republic to that in Dominica?
Keep it short and to the point. 83.33. What is the ratio of the Number of enrolments of both sexes in Secondary vocational in Czech Republic to that in Dominica?
Make the answer very short. 0.38. What is the ratio of the Number of enrolments of both sexes in Primary in Czech Republic to that in Dominican Republic?
Make the answer very short. 0.41. What is the ratio of the Number of enrolments of both sexes of Secondary in Czech Republic to that in Dominican Republic?
Your answer should be compact. 0.26. What is the ratio of the Number of enrolments of both sexes in Secondary general in Czech Republic to that in Dominican Republic?
Keep it short and to the point. 0.81. What is the ratio of the Number of enrolments of both sexes of Secondary vocational in Czech Republic to that in Dominican Republic?
Make the answer very short. 0.05. What is the ratio of the Number of enrolments of both sexes of Primary in Czech Republic to that in Ecuador?
Give a very brief answer. 0.29. What is the ratio of the Number of enrolments of both sexes of Secondary in Czech Republic to that in Ecuador?
Keep it short and to the point. 4.92. What is the ratio of the Number of enrolments of both sexes in Secondary general in Czech Republic to that in Ecuador?
Your answer should be compact. 0.1. What is the ratio of the Number of enrolments of both sexes in Secondary vocational in Czech Republic to that in Ecuador?
Offer a terse response. 6.91. What is the ratio of the Number of enrolments of both sexes in Primary in Djibouti to that in Dominica?
Provide a succinct answer. 4.43. What is the ratio of the Number of enrolments of both sexes in Secondary in Djibouti to that in Dominica?
Your answer should be very brief. 1.31. What is the ratio of the Number of enrolments of both sexes of Secondary general in Djibouti to that in Dominica?
Your answer should be compact. 44.89. What is the ratio of the Number of enrolments of both sexes of Secondary vocational in Djibouti to that in Dominica?
Your answer should be very brief. 0.01. What is the ratio of the Number of enrolments of both sexes in Primary in Djibouti to that in Dominican Republic?
Give a very brief answer. 0.03. What is the ratio of the Number of enrolments of both sexes in Secondary in Djibouti to that in Dominican Republic?
Make the answer very short. 0.09. What is the ratio of the Number of enrolments of both sexes of Secondary general in Djibouti to that in Dominican Republic?
Your answer should be compact. 0.43. What is the ratio of the Number of enrolments of both sexes in Secondary vocational in Djibouti to that in Dominican Republic?
Give a very brief answer. 0. What is the ratio of the Number of enrolments of both sexes of Primary in Djibouti to that in Ecuador?
Provide a short and direct response. 0.02. What is the ratio of the Number of enrolments of both sexes of Secondary in Djibouti to that in Ecuador?
Give a very brief answer. 1.63. What is the ratio of the Number of enrolments of both sexes in Secondary general in Djibouti to that in Ecuador?
Your answer should be very brief. 0.06. What is the ratio of the Number of enrolments of both sexes in Secondary vocational in Djibouti to that in Ecuador?
Make the answer very short. 0.22. What is the ratio of the Number of enrolments of both sexes in Primary in Dominica to that in Dominican Republic?
Give a very brief answer. 0.01. What is the ratio of the Number of enrolments of both sexes of Secondary in Dominica to that in Dominican Republic?
Provide a short and direct response. 0.07. What is the ratio of the Number of enrolments of both sexes in Secondary general in Dominica to that in Dominican Republic?
Offer a terse response. 0.01. What is the ratio of the Number of enrolments of both sexes in Secondary vocational in Dominica to that in Dominican Republic?
Make the answer very short. 0.13. What is the ratio of the Number of enrolments of both sexes in Primary in Dominica to that in Ecuador?
Offer a terse response. 0.01. What is the ratio of the Number of enrolments of both sexes in Secondary in Dominica to that in Ecuador?
Provide a short and direct response. 1.24. What is the ratio of the Number of enrolments of both sexes of Secondary general in Dominica to that in Ecuador?
Make the answer very short. 0. What is the ratio of the Number of enrolments of both sexes of Secondary vocational in Dominica to that in Ecuador?
Provide a short and direct response. 18.12. What is the ratio of the Number of enrolments of both sexes in Primary in Dominican Republic to that in Ecuador?
Offer a very short reply. 0.69. What is the ratio of the Number of enrolments of both sexes in Secondary in Dominican Republic to that in Ecuador?
Offer a very short reply. 18.73. What is the ratio of the Number of enrolments of both sexes of Secondary general in Dominican Republic to that in Ecuador?
Your answer should be compact. 0.13. What is the ratio of the Number of enrolments of both sexes of Secondary vocational in Dominican Republic to that in Ecuador?
Your answer should be compact. 139.48. What is the difference between the highest and the second highest Number of enrolments of both sexes of Primary?
Your answer should be compact. 6.13e+05. What is the difference between the highest and the second highest Number of enrolments of both sexes in Secondary?
Provide a short and direct response. 6.53e+06. What is the difference between the highest and the second highest Number of enrolments of both sexes in Secondary general?
Give a very brief answer. 5.11e+06. What is the difference between the highest and the second highest Number of enrolments of both sexes in Secondary vocational?
Your response must be concise. 1.27e+06. What is the difference between the highest and the lowest Number of enrolments of both sexes in Primary?
Give a very brief answer. 1.98e+06. What is the difference between the highest and the lowest Number of enrolments of both sexes in Secondary?
Offer a terse response. 8.28e+06. What is the difference between the highest and the lowest Number of enrolments of both sexes of Secondary general?
Ensure brevity in your answer.  5.86e+06. What is the difference between the highest and the lowest Number of enrolments of both sexes of Secondary vocational?
Your answer should be very brief. 1.45e+06. 